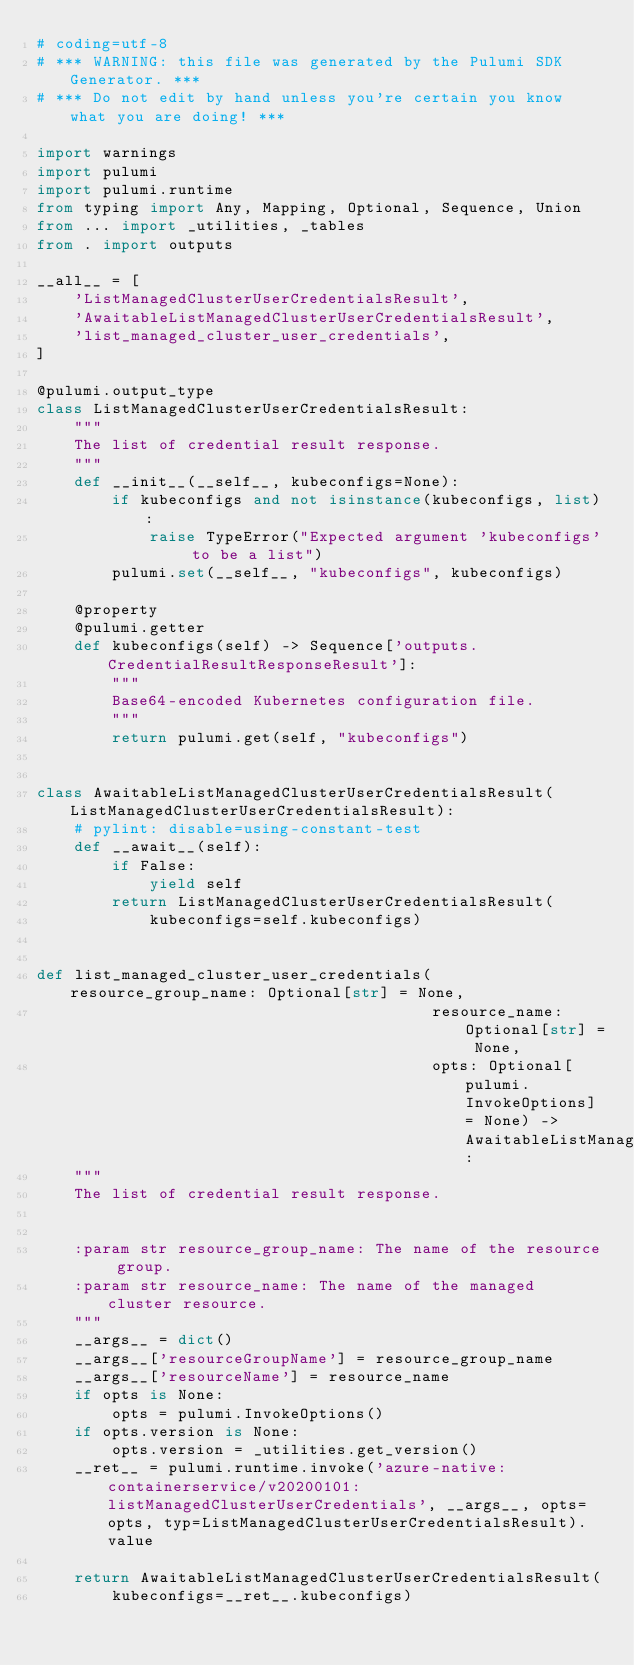Convert code to text. <code><loc_0><loc_0><loc_500><loc_500><_Python_># coding=utf-8
# *** WARNING: this file was generated by the Pulumi SDK Generator. ***
# *** Do not edit by hand unless you're certain you know what you are doing! ***

import warnings
import pulumi
import pulumi.runtime
from typing import Any, Mapping, Optional, Sequence, Union
from ... import _utilities, _tables
from . import outputs

__all__ = [
    'ListManagedClusterUserCredentialsResult',
    'AwaitableListManagedClusterUserCredentialsResult',
    'list_managed_cluster_user_credentials',
]

@pulumi.output_type
class ListManagedClusterUserCredentialsResult:
    """
    The list of credential result response.
    """
    def __init__(__self__, kubeconfigs=None):
        if kubeconfigs and not isinstance(kubeconfigs, list):
            raise TypeError("Expected argument 'kubeconfigs' to be a list")
        pulumi.set(__self__, "kubeconfigs", kubeconfigs)

    @property
    @pulumi.getter
    def kubeconfigs(self) -> Sequence['outputs.CredentialResultResponseResult']:
        """
        Base64-encoded Kubernetes configuration file.
        """
        return pulumi.get(self, "kubeconfigs")


class AwaitableListManagedClusterUserCredentialsResult(ListManagedClusterUserCredentialsResult):
    # pylint: disable=using-constant-test
    def __await__(self):
        if False:
            yield self
        return ListManagedClusterUserCredentialsResult(
            kubeconfigs=self.kubeconfigs)


def list_managed_cluster_user_credentials(resource_group_name: Optional[str] = None,
                                          resource_name: Optional[str] = None,
                                          opts: Optional[pulumi.InvokeOptions] = None) -> AwaitableListManagedClusterUserCredentialsResult:
    """
    The list of credential result response.


    :param str resource_group_name: The name of the resource group.
    :param str resource_name: The name of the managed cluster resource.
    """
    __args__ = dict()
    __args__['resourceGroupName'] = resource_group_name
    __args__['resourceName'] = resource_name
    if opts is None:
        opts = pulumi.InvokeOptions()
    if opts.version is None:
        opts.version = _utilities.get_version()
    __ret__ = pulumi.runtime.invoke('azure-native:containerservice/v20200101:listManagedClusterUserCredentials', __args__, opts=opts, typ=ListManagedClusterUserCredentialsResult).value

    return AwaitableListManagedClusterUserCredentialsResult(
        kubeconfigs=__ret__.kubeconfigs)
</code> 